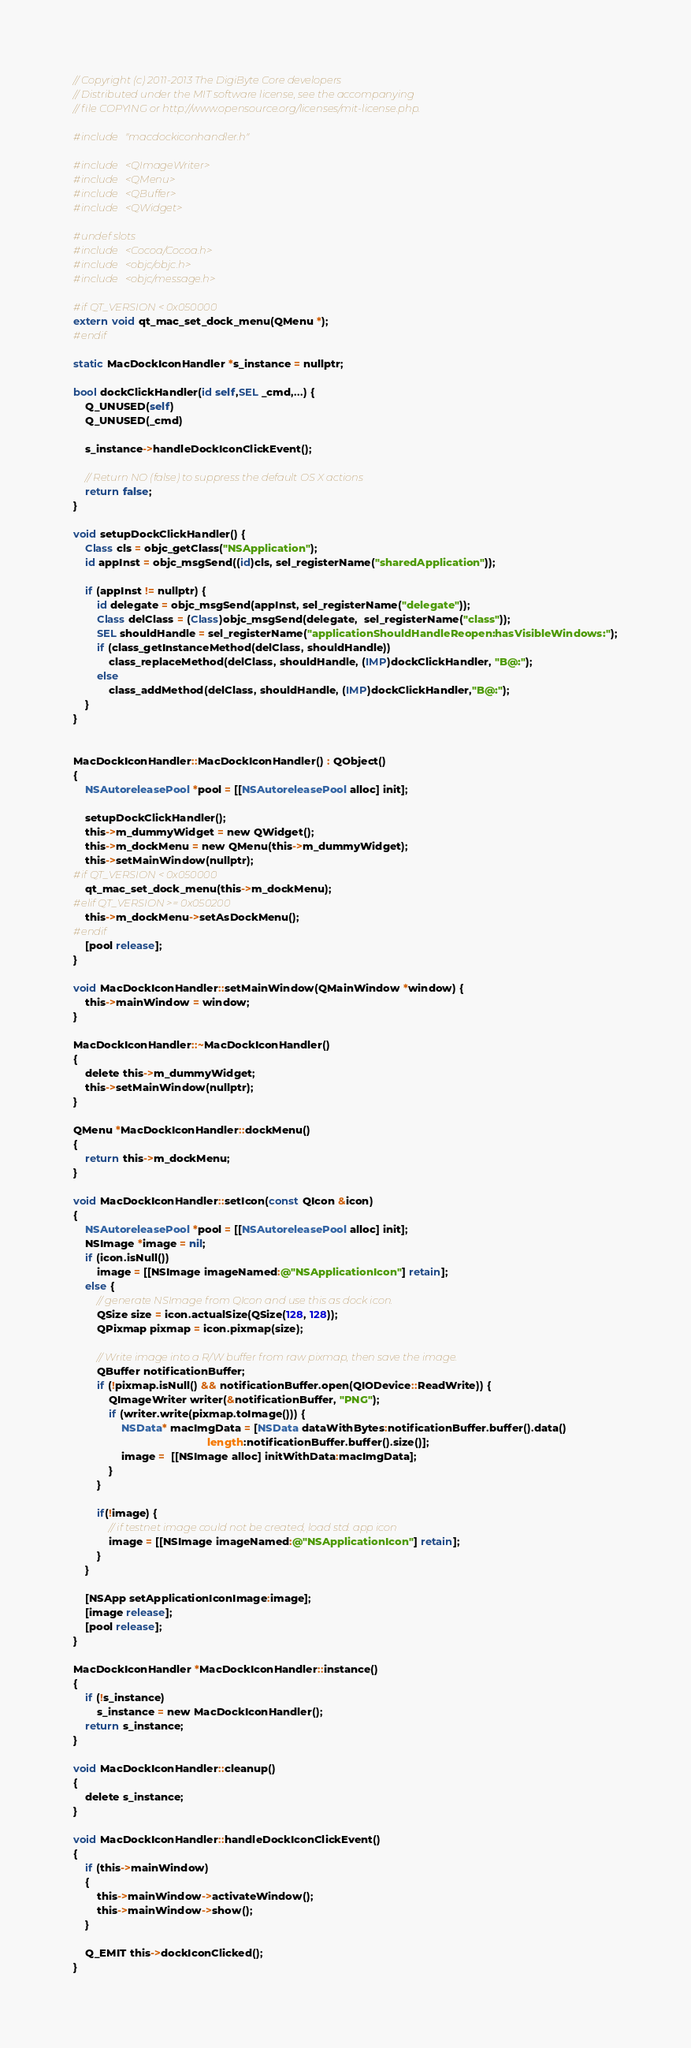<code> <loc_0><loc_0><loc_500><loc_500><_ObjectiveC_>// Copyright (c) 2011-2013 The DigiByte Core developers
// Distributed under the MIT software license, see the accompanying
// file COPYING or http://www.opensource.org/licenses/mit-license.php.

#include "macdockiconhandler.h"

#include <QImageWriter>
#include <QMenu>
#include <QBuffer>
#include <QWidget>

#undef slots
#include <Cocoa/Cocoa.h>
#include <objc/objc.h>
#include <objc/message.h>

#if QT_VERSION < 0x050000
extern void qt_mac_set_dock_menu(QMenu *);
#endif

static MacDockIconHandler *s_instance = nullptr;

bool dockClickHandler(id self,SEL _cmd,...) {
    Q_UNUSED(self)
    Q_UNUSED(_cmd)
    
    s_instance->handleDockIconClickEvent();
    
    // Return NO (false) to suppress the default OS X actions
    return false;
}

void setupDockClickHandler() {
    Class cls = objc_getClass("NSApplication");
    id appInst = objc_msgSend((id)cls, sel_registerName("sharedApplication"));
    
    if (appInst != nullptr) {
        id delegate = objc_msgSend(appInst, sel_registerName("delegate"));
        Class delClass = (Class)objc_msgSend(delegate,  sel_registerName("class"));
        SEL shouldHandle = sel_registerName("applicationShouldHandleReopen:hasVisibleWindows:");
        if (class_getInstanceMethod(delClass, shouldHandle))
            class_replaceMethod(delClass, shouldHandle, (IMP)dockClickHandler, "B@:");
        else
            class_addMethod(delClass, shouldHandle, (IMP)dockClickHandler,"B@:");
    }
}


MacDockIconHandler::MacDockIconHandler() : QObject()
{
    NSAutoreleasePool *pool = [[NSAutoreleasePool alloc] init];

    setupDockClickHandler();
    this->m_dummyWidget = new QWidget();
    this->m_dockMenu = new QMenu(this->m_dummyWidget);
    this->setMainWindow(nullptr);
#if QT_VERSION < 0x050000
    qt_mac_set_dock_menu(this->m_dockMenu);
#elif QT_VERSION >= 0x050200
    this->m_dockMenu->setAsDockMenu();
#endif
    [pool release];
}

void MacDockIconHandler::setMainWindow(QMainWindow *window) {
    this->mainWindow = window;
}

MacDockIconHandler::~MacDockIconHandler()
{
    delete this->m_dummyWidget;
    this->setMainWindow(nullptr);
}

QMenu *MacDockIconHandler::dockMenu()
{
    return this->m_dockMenu;
}

void MacDockIconHandler::setIcon(const QIcon &icon)
{
    NSAutoreleasePool *pool = [[NSAutoreleasePool alloc] init];
    NSImage *image = nil;
    if (icon.isNull())
        image = [[NSImage imageNamed:@"NSApplicationIcon"] retain];
    else {
        // generate NSImage from QIcon and use this as dock icon.
        QSize size = icon.actualSize(QSize(128, 128));
        QPixmap pixmap = icon.pixmap(size);

        // Write image into a R/W buffer from raw pixmap, then save the image.
        QBuffer notificationBuffer;
        if (!pixmap.isNull() && notificationBuffer.open(QIODevice::ReadWrite)) {
            QImageWriter writer(&notificationBuffer, "PNG");
            if (writer.write(pixmap.toImage())) {
                NSData* macImgData = [NSData dataWithBytes:notificationBuffer.buffer().data()
                                             length:notificationBuffer.buffer().size()];
                image =  [[NSImage alloc] initWithData:macImgData];
            }
        }

        if(!image) {
            // if testnet image could not be created, load std. app icon
            image = [[NSImage imageNamed:@"NSApplicationIcon"] retain];
        }
    }

    [NSApp setApplicationIconImage:image];
    [image release];
    [pool release];
}

MacDockIconHandler *MacDockIconHandler::instance()
{
    if (!s_instance)
        s_instance = new MacDockIconHandler();
    return s_instance;
}

void MacDockIconHandler::cleanup()
{
    delete s_instance;
}

void MacDockIconHandler::handleDockIconClickEvent()
{
    if (this->mainWindow)
    {
        this->mainWindow->activateWindow();
        this->mainWindow->show();
    }

    Q_EMIT this->dockIconClicked();
}
</code> 